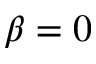<formula> <loc_0><loc_0><loc_500><loc_500>\beta = 0</formula> 